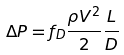<formula> <loc_0><loc_0><loc_500><loc_500>\Delta P = f _ { D } \frac { \rho V ^ { 2 } } { 2 } \frac { L } { D }</formula> 